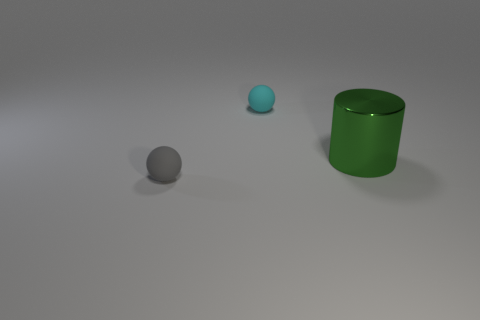Add 3 cyan rubber objects. How many objects exist? 6 Subtract all gray spheres. How many spheres are left? 1 Subtract all tiny gray rubber objects. Subtract all big cylinders. How many objects are left? 1 Add 3 metal cylinders. How many metal cylinders are left? 4 Add 3 tiny cyan metal cylinders. How many tiny cyan metal cylinders exist? 3 Subtract 0 red cubes. How many objects are left? 3 Subtract all balls. How many objects are left? 1 Subtract all gray cylinders. Subtract all blue balls. How many cylinders are left? 1 Subtract all red cubes. How many blue balls are left? 0 